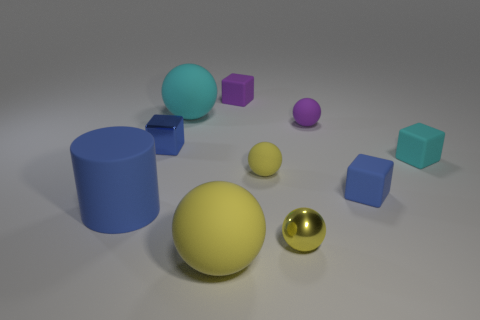How many yellow balls must be subtracted to get 1 yellow balls? 2 Subtract all purple matte cubes. How many cubes are left? 3 Subtract all cubes. How many objects are left? 6 Subtract 1 blocks. How many blocks are left? 3 Subtract all purple spheres. How many spheres are left? 4 Subtract 0 brown balls. How many objects are left? 10 Subtract all brown cubes. Subtract all purple spheres. How many cubes are left? 4 Subtract all gray cylinders. How many purple balls are left? 1 Subtract all large yellow matte things. Subtract all small cubes. How many objects are left? 5 Add 8 tiny metal blocks. How many tiny metal blocks are left? 9 